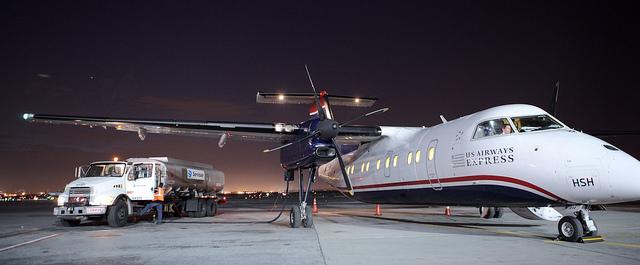What are color are the two streams of light?
Write a very short answer. Yellow. What is the relationship of the truck to the plane?
Be succinct. Fuel. What is the object between the truck and plane?
Quick response, please. Hose. Is this an express flight?
Keep it brief. Yes. 